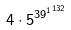Convert formula to latex. <formula><loc_0><loc_0><loc_500><loc_500>4 \cdot 5 ^ { { 3 9 ^ { 1 } } ^ { 1 3 2 } }</formula> 